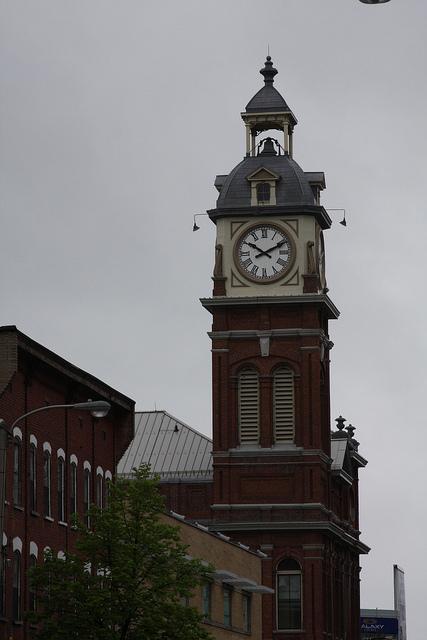What time does the clock show?
Quick response, please. 10:10. Is this a castle?
Answer briefly. No. Is this big ben?
Give a very brief answer. No. What is the metal that most likely makes up the top of this tower?
Keep it brief. Steel. What time is it?
Answer briefly. 10:10. How many windows above the clock?
Write a very short answer. 1. Is the weather sunny?
Write a very short answer. No. Is there a bell on the top of the building?
Be succinct. Yes. How many clocks are on this tower?
Answer briefly. 1. What is the color of the very tip of this building?
Answer briefly. Gray. What time is on the clock?
Write a very short answer. 10:10. Is this a cloudy day?
Concise answer only. Yes. How many hours, minutes and seconds are displayed on this clock?
Be succinct. 10 hours 10 minutes 10 seconds. What time does the large clock say it is?
Write a very short answer. 10:10. Is it going to rain?
Be succinct. Yes. What is on top of the clock?
Keep it brief. Bell. What color is the top of the tower?
Answer briefly. Gray. 